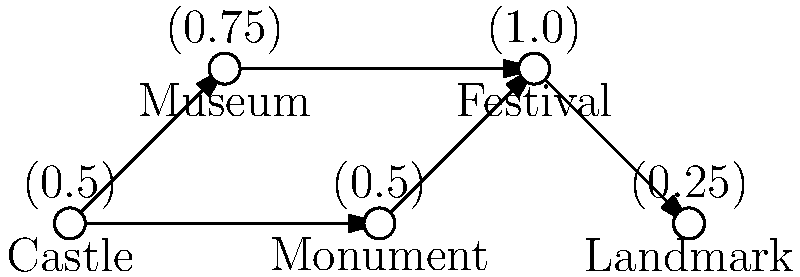In the network diagram representing the relationship between historical landmarks and regional identity formation, which node has the highest betweenness centrality, and how might this impact the development of regional autonomy movements? To answer this question, we need to follow these steps:

1. Understand betweenness centrality:
   Betweenness centrality measures how often a node appears on the shortest paths between other nodes in the network. It indicates how important a node is in connecting different parts of the network.

2. Analyze the network structure:
   The network shows five nodes: Castle, Museum, Monument, Festival, and Landmark. The arrows indicate the flow of influence or connection between these elements.

3. Identify the node with the highest betweenness centrality:
   The Festival node has the highest centrality value (1.0), indicating it appears most frequently on the shortest paths between other nodes.

4. Interpret the impact on regional autonomy movements:
   The Festival node's high centrality suggests that it plays a crucial role in connecting various aspects of regional identity. This could impact regional autonomy movements in several ways:

   a) Cultural cohesion: Festivals can bring together diverse elements of regional heritage, fostering a sense of shared identity.
   b) Visibility: High-centrality events can amplify regional distinctiveness, potentially strengthening arguments for autonomy.
   c) Network mobilization: Festivals can serve as hubs for organizing and disseminating information related to autonomy movements.
   d) Economic impact: Popular festivals can demonstrate a region's capacity for self-governance through successful event management.

5. Consider the role of other nodes:
   While the Festival node is central, the connections to other historical landmarks (Castle, Monument) and cultural institutions (Museum) contribute to a comprehensive regional identity narrative.

The high betweenness centrality of the Festival node suggests that cultural events play a pivotal role in shaping and connecting various aspects of regional identity, potentially serving as a catalyst for autonomy movements by strengthening cultural cohesion and regional distinctiveness.
Answer: Festival node; amplifies regional identity, connecting cultural elements and potentially catalyzing autonomy movements. 